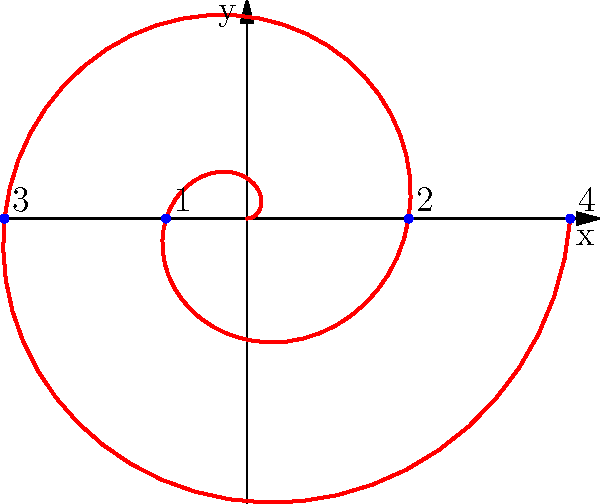As the community engagement coordinator, you're analyzing the growth of participation in local events over time. The spiral pattern above represents this growth, with each complete revolution corresponding to a year. If the radial distance from the origin represents the number of participants, and point 4 indicates the current participation level after 2 years, what is the average rate of increase in participants per year? To solve this problem, let's follow these steps:

1) First, we need to understand what the spiral represents:
   - Each complete revolution (2π radians) represents one year
   - The radial distance from the origin represents the number of participants

2) We're interested in point 4, which is after 2 complete revolutions (4π radians)

3) In polar coordinates, the equation of this spiral is given by $r = a\theta$, where:
   - $r$ is the radial distance
   - $a$ is a constant determining the rate of spiral expansion
   - $\theta$ is the angle in radians

4) At point 4, we have:
   $r = a(4\pi)$

5) To find $a$, we need to know the radial distance at point 4. From the graph, we can see it's approximately 2.5 units.

6) So, we can write:
   $2.5 = a(4\pi)$
   $a = \frac{2.5}{4\pi} \approx 0.1989$

7) This means that for every radian, the radius (number of participants) increases by about 0.1989 units.

8) To find the increase per year, we multiply this by $2\pi$ (as there are $2\pi$ radians in a complete revolution):
   $0.1989 * 2\pi \approx 1.25$

9) Therefore, the number of participants increases by about 1.25 units per year.

10) As we started from 0 and reached 2.5 in 2 years, this confirms our calculation:
    $1.25 * 2 = 2.5$

Thus, the average rate of increase is 1.25 participants per year.
Answer: 1.25 participants/year 